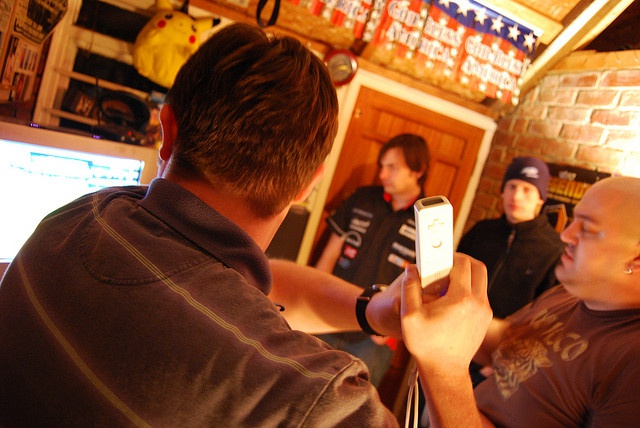Describe the objects in this image and their specific colors. I can see people in maroon, black, and brown tones, people in maroon, red, brown, and black tones, tv in maroon, white, tan, salmon, and brown tones, people in maroon, black, red, and brown tones, and people in maroon, black, orange, and brown tones in this image. 